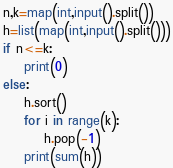Convert code to text. <code><loc_0><loc_0><loc_500><loc_500><_Python_>n,k=map(int,input().split())
h=list(map(int,input().split()))
if n<=k:
    print(0)
else:
    h.sort()
    for i in range(k):
        h.pop(-1)
    print(sum(h))</code> 